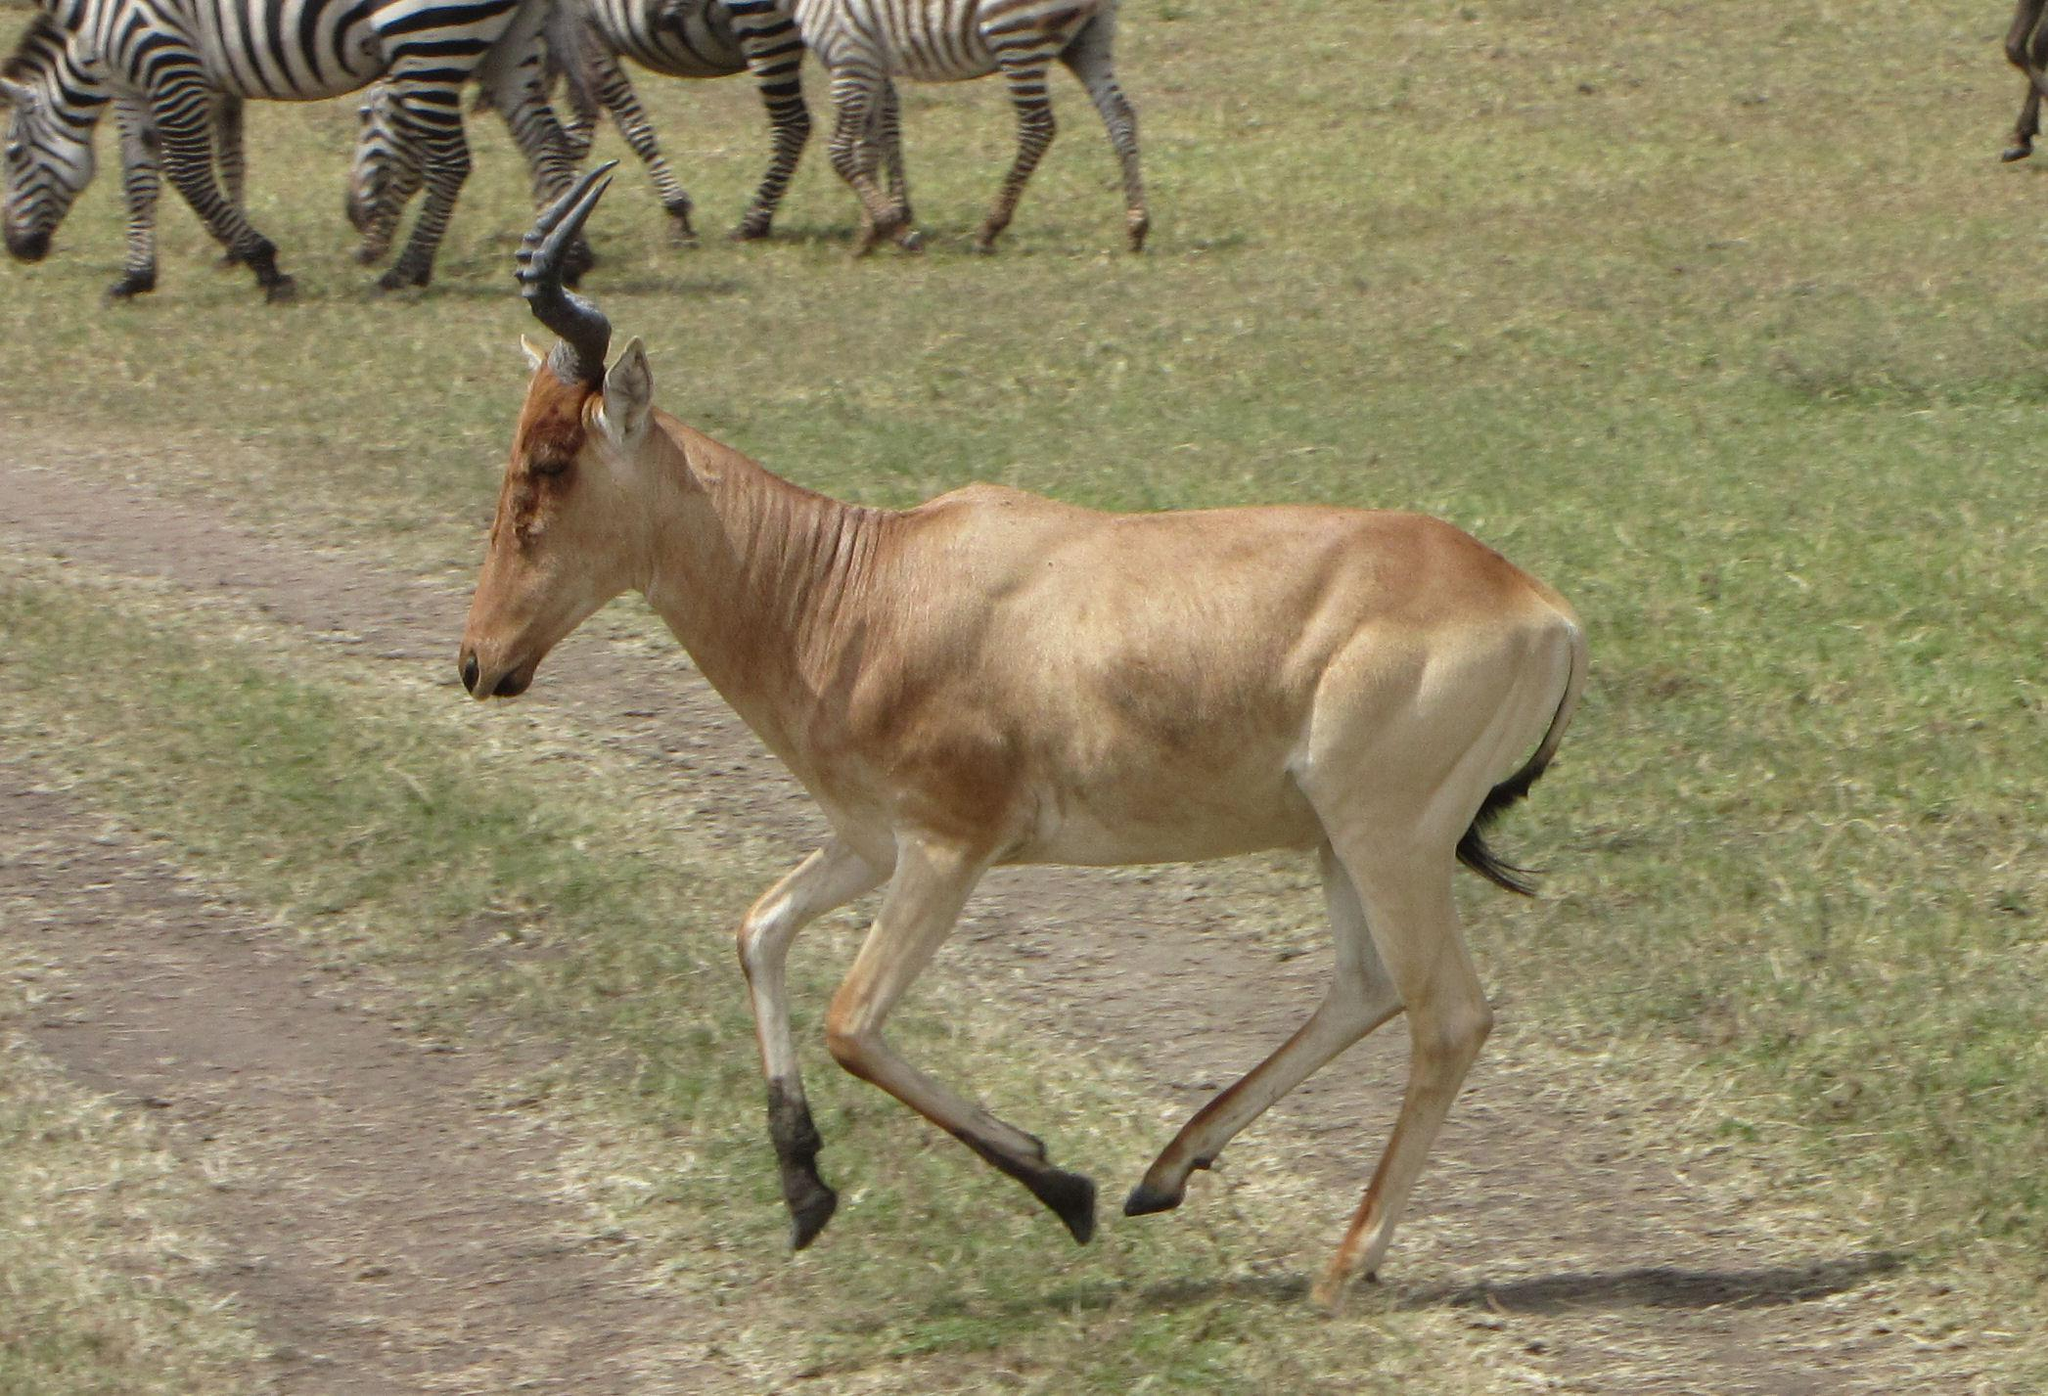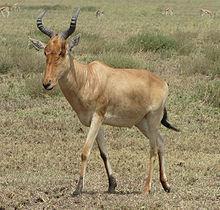The first image is the image on the left, the second image is the image on the right. For the images shown, is this caption "There are two antelopes, both facing left." true? Answer yes or no. Yes. The first image is the image on the left, the second image is the image on the right. Evaluate the accuracy of this statement regarding the images: "Each image contains a single horned animal in the foreground, and the animal's body is turned leftward.". Is it true? Answer yes or no. Yes. 